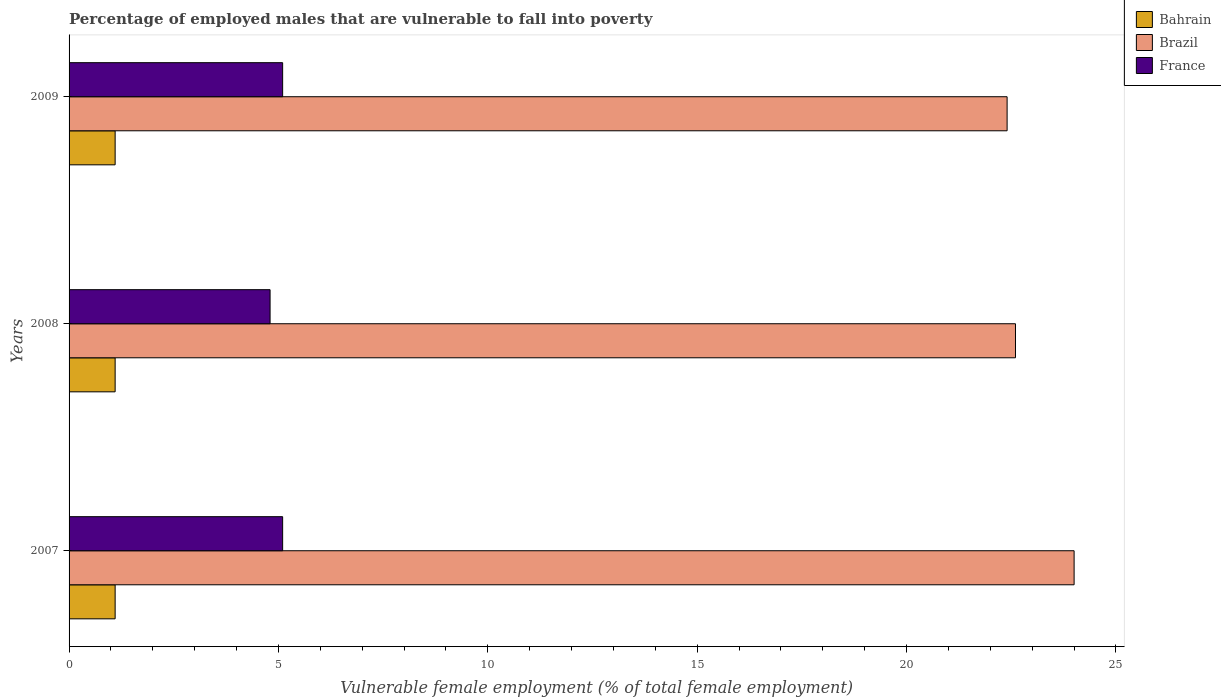How many different coloured bars are there?
Your response must be concise. 3. How many groups of bars are there?
Offer a terse response. 3. Are the number of bars on each tick of the Y-axis equal?
Make the answer very short. Yes. How many bars are there on the 2nd tick from the top?
Your response must be concise. 3. What is the label of the 2nd group of bars from the top?
Your response must be concise. 2008. In how many cases, is the number of bars for a given year not equal to the number of legend labels?
Offer a very short reply. 0. What is the percentage of employed males who are vulnerable to fall into poverty in France in 2007?
Offer a terse response. 5.1. Across all years, what is the maximum percentage of employed males who are vulnerable to fall into poverty in Bahrain?
Keep it short and to the point. 1.1. Across all years, what is the minimum percentage of employed males who are vulnerable to fall into poverty in France?
Your response must be concise. 4.8. In which year was the percentage of employed males who are vulnerable to fall into poverty in Bahrain maximum?
Ensure brevity in your answer.  2007. What is the total percentage of employed males who are vulnerable to fall into poverty in Brazil in the graph?
Give a very brief answer. 69. What is the difference between the percentage of employed males who are vulnerable to fall into poverty in France in 2008 and the percentage of employed males who are vulnerable to fall into poverty in Bahrain in 2007?
Keep it short and to the point. 3.7. What is the average percentage of employed males who are vulnerable to fall into poverty in Bahrain per year?
Make the answer very short. 1.1. In the year 2008, what is the difference between the percentage of employed males who are vulnerable to fall into poverty in Brazil and percentage of employed males who are vulnerable to fall into poverty in Bahrain?
Ensure brevity in your answer.  21.5. What is the ratio of the percentage of employed males who are vulnerable to fall into poverty in France in 2007 to that in 2008?
Provide a succinct answer. 1.06. Is the difference between the percentage of employed males who are vulnerable to fall into poverty in Brazil in 2007 and 2008 greater than the difference between the percentage of employed males who are vulnerable to fall into poverty in Bahrain in 2007 and 2008?
Your response must be concise. Yes. What is the difference between the highest and the second highest percentage of employed males who are vulnerable to fall into poverty in Brazil?
Provide a succinct answer. 1.4. What does the 3rd bar from the top in 2009 represents?
Provide a short and direct response. Bahrain. What does the 1st bar from the bottom in 2008 represents?
Your answer should be compact. Bahrain. How many bars are there?
Offer a very short reply. 9. How many years are there in the graph?
Provide a succinct answer. 3. What is the difference between two consecutive major ticks on the X-axis?
Provide a short and direct response. 5. Does the graph contain grids?
Your response must be concise. No. Where does the legend appear in the graph?
Ensure brevity in your answer.  Top right. How many legend labels are there?
Ensure brevity in your answer.  3. What is the title of the graph?
Offer a terse response. Percentage of employed males that are vulnerable to fall into poverty. What is the label or title of the X-axis?
Your response must be concise. Vulnerable female employment (% of total female employment). What is the label or title of the Y-axis?
Give a very brief answer. Years. What is the Vulnerable female employment (% of total female employment) of Bahrain in 2007?
Keep it short and to the point. 1.1. What is the Vulnerable female employment (% of total female employment) in Brazil in 2007?
Provide a short and direct response. 24. What is the Vulnerable female employment (% of total female employment) in France in 2007?
Your answer should be very brief. 5.1. What is the Vulnerable female employment (% of total female employment) of Bahrain in 2008?
Provide a short and direct response. 1.1. What is the Vulnerable female employment (% of total female employment) of Brazil in 2008?
Give a very brief answer. 22.6. What is the Vulnerable female employment (% of total female employment) of France in 2008?
Provide a short and direct response. 4.8. What is the Vulnerable female employment (% of total female employment) in Bahrain in 2009?
Ensure brevity in your answer.  1.1. What is the Vulnerable female employment (% of total female employment) in Brazil in 2009?
Offer a terse response. 22.4. What is the Vulnerable female employment (% of total female employment) of France in 2009?
Make the answer very short. 5.1. Across all years, what is the maximum Vulnerable female employment (% of total female employment) in Bahrain?
Provide a short and direct response. 1.1. Across all years, what is the maximum Vulnerable female employment (% of total female employment) in France?
Your answer should be compact. 5.1. Across all years, what is the minimum Vulnerable female employment (% of total female employment) in Bahrain?
Offer a terse response. 1.1. Across all years, what is the minimum Vulnerable female employment (% of total female employment) in Brazil?
Keep it short and to the point. 22.4. Across all years, what is the minimum Vulnerable female employment (% of total female employment) in France?
Offer a very short reply. 4.8. What is the total Vulnerable female employment (% of total female employment) of Brazil in the graph?
Provide a succinct answer. 69. What is the difference between the Vulnerable female employment (% of total female employment) in Brazil in 2007 and that in 2008?
Give a very brief answer. 1.4. What is the difference between the Vulnerable female employment (% of total female employment) of Brazil in 2007 and that in 2009?
Keep it short and to the point. 1.6. What is the difference between the Vulnerable female employment (% of total female employment) of France in 2007 and that in 2009?
Keep it short and to the point. 0. What is the difference between the Vulnerable female employment (% of total female employment) of Bahrain in 2008 and that in 2009?
Make the answer very short. 0. What is the difference between the Vulnerable female employment (% of total female employment) of Bahrain in 2007 and the Vulnerable female employment (% of total female employment) of Brazil in 2008?
Ensure brevity in your answer.  -21.5. What is the difference between the Vulnerable female employment (% of total female employment) in Bahrain in 2007 and the Vulnerable female employment (% of total female employment) in Brazil in 2009?
Your response must be concise. -21.3. What is the difference between the Vulnerable female employment (% of total female employment) in Bahrain in 2007 and the Vulnerable female employment (% of total female employment) in France in 2009?
Make the answer very short. -4. What is the difference between the Vulnerable female employment (% of total female employment) of Bahrain in 2008 and the Vulnerable female employment (% of total female employment) of Brazil in 2009?
Your answer should be compact. -21.3. What is the difference between the Vulnerable female employment (% of total female employment) of Bahrain in 2008 and the Vulnerable female employment (% of total female employment) of France in 2009?
Keep it short and to the point. -4. What is the difference between the Vulnerable female employment (% of total female employment) in Brazil in 2008 and the Vulnerable female employment (% of total female employment) in France in 2009?
Ensure brevity in your answer.  17.5. What is the average Vulnerable female employment (% of total female employment) in Brazil per year?
Keep it short and to the point. 23. What is the average Vulnerable female employment (% of total female employment) of France per year?
Your answer should be very brief. 5. In the year 2007, what is the difference between the Vulnerable female employment (% of total female employment) of Bahrain and Vulnerable female employment (% of total female employment) of Brazil?
Your answer should be very brief. -22.9. In the year 2007, what is the difference between the Vulnerable female employment (% of total female employment) in Bahrain and Vulnerable female employment (% of total female employment) in France?
Provide a succinct answer. -4. In the year 2007, what is the difference between the Vulnerable female employment (% of total female employment) in Brazil and Vulnerable female employment (% of total female employment) in France?
Offer a very short reply. 18.9. In the year 2008, what is the difference between the Vulnerable female employment (% of total female employment) of Bahrain and Vulnerable female employment (% of total female employment) of Brazil?
Your answer should be compact. -21.5. In the year 2008, what is the difference between the Vulnerable female employment (% of total female employment) of Bahrain and Vulnerable female employment (% of total female employment) of France?
Your answer should be very brief. -3.7. In the year 2008, what is the difference between the Vulnerable female employment (% of total female employment) of Brazil and Vulnerable female employment (% of total female employment) of France?
Give a very brief answer. 17.8. In the year 2009, what is the difference between the Vulnerable female employment (% of total female employment) in Bahrain and Vulnerable female employment (% of total female employment) in Brazil?
Offer a very short reply. -21.3. In the year 2009, what is the difference between the Vulnerable female employment (% of total female employment) of Bahrain and Vulnerable female employment (% of total female employment) of France?
Your answer should be very brief. -4. What is the ratio of the Vulnerable female employment (% of total female employment) of Brazil in 2007 to that in 2008?
Offer a terse response. 1.06. What is the ratio of the Vulnerable female employment (% of total female employment) in Bahrain in 2007 to that in 2009?
Make the answer very short. 1. What is the ratio of the Vulnerable female employment (% of total female employment) of Brazil in 2007 to that in 2009?
Make the answer very short. 1.07. What is the ratio of the Vulnerable female employment (% of total female employment) of France in 2007 to that in 2009?
Give a very brief answer. 1. What is the ratio of the Vulnerable female employment (% of total female employment) in Brazil in 2008 to that in 2009?
Give a very brief answer. 1.01. What is the difference between the highest and the lowest Vulnerable female employment (% of total female employment) in France?
Provide a succinct answer. 0.3. 